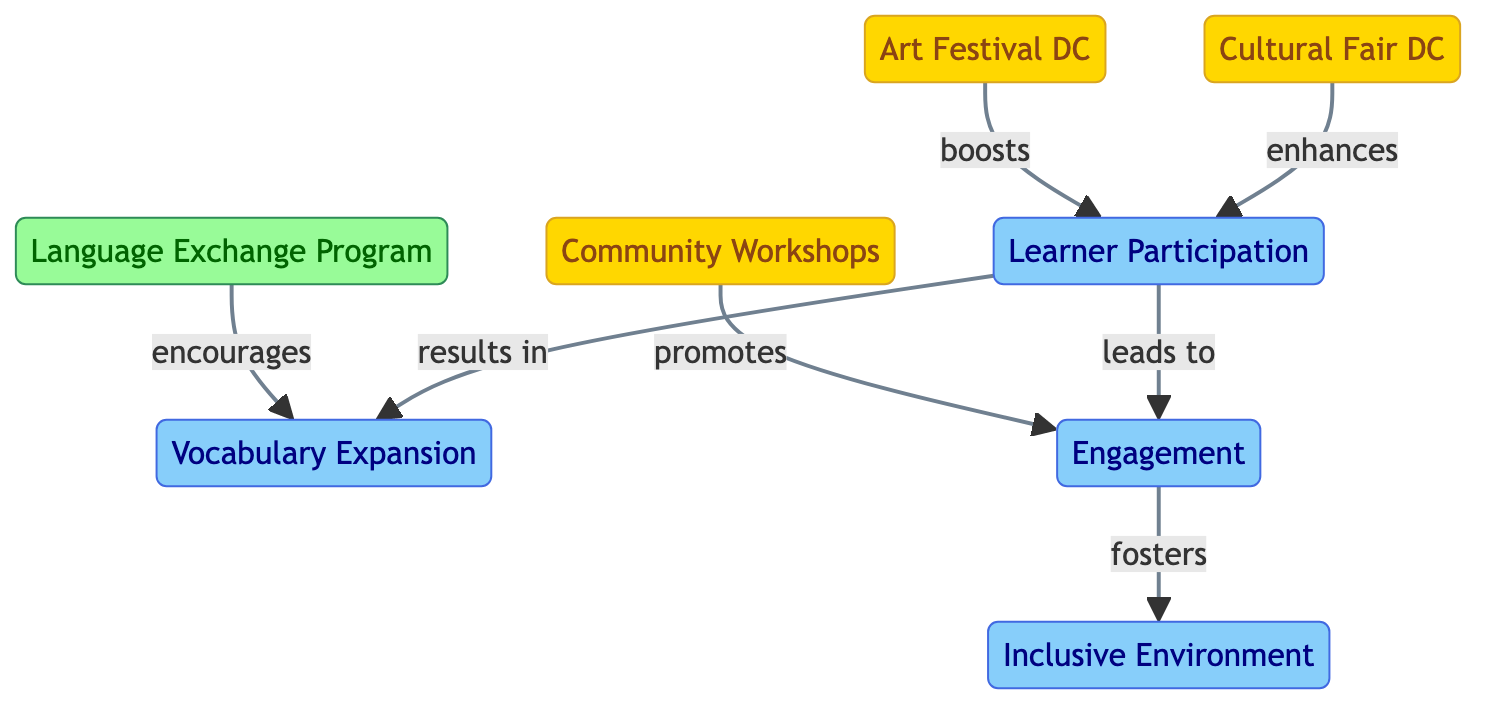What are the three events listed in the diagram? The nodes identified as events include Art Festival DC, Cultural Fair DC, and Community Workshops. These are explicitly labeled as "event" types in the diagram.
Answer: Art Festival DC, Cultural Fair DC, Community Workshops How many impacts are represented in the diagram? In the diagram, the impacts represented are Learner Participation, Vocabulary Expansion, Engagement, and Inclusive Environment, totaling four impact nodes.
Answer: 4 What relationship does the Language Exchange Program have with Vocabulary Expansion? The diagram indicates that the Language Exchange Program "encourages" Vocabulary Expansion, establishing a direct connection between these two nodes.
Answer: encourages What does Learner Participation lead to? According to the diagram, Learner Participation "leads to" Engagement and "results in" Vocabulary Expansion, so it has two outcomes in terms of relationships.
Answer: Engagement, Vocabulary Expansion Which event boosts Learner Participation? The diagram suggests that the Art Festival DC boosts Learner Participation, establishing a positive relationship between the event and the impact.
Answer: boosts What is the effect of Engagement on Inclusive Environment? Engagement in the diagram "fosters" an Inclusive Environment, indicating a supportive relationship between the two nodes that enhances community dynamics.
Answer: fosters Which community event enhances Learner Participation? The Cultural Fair DC is indicated to enhance Learner Participation within the network, promoting a positive influence from that event.
Answer: enhances How many edges connect the impact nodes? The diagram shows that there are a total of five edges that connect the impact nodes: Learner Participation connects to Engagement and Vocabulary Expansion, and Engagement connects to Inclusive Environment.
Answer: 5 What event promotes Engagement? Community Workshops, as depicted in the diagram, promotes Engagement, establishing a direct link that shows the event's effect on that impact.
Answer: promotes 